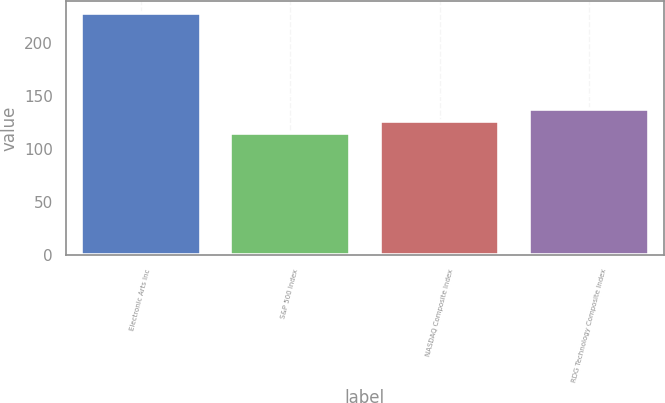Convert chart to OTSL. <chart><loc_0><loc_0><loc_500><loc_500><bar_chart><fcel>Electronic Arts Inc<fcel>S&P 500 Index<fcel>NASDAQ Composite Index<fcel>RDG Technology Composite Index<nl><fcel>228<fcel>115<fcel>126.3<fcel>137.6<nl></chart> 